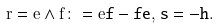Convert formula to latex. <formula><loc_0><loc_0><loc_500><loc_500>r = e \wedge f \colon = e \tt f - f \tt e , \, s = - h .</formula> 